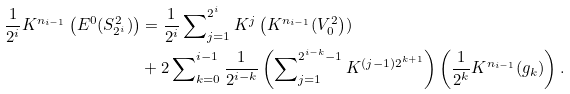Convert formula to latex. <formula><loc_0><loc_0><loc_500><loc_500>\frac { 1 } { 2 ^ { i } } K ^ { n _ { i - 1 } } \left ( E ^ { 0 } ( S _ { 2 ^ { i } } ^ { 2 } ) \right ) & = \frac { 1 } { 2 ^ { i } } \sum \nolimits _ { j = 1 } ^ { 2 ^ { i } } K ^ { j } \left ( K ^ { n _ { i - 1 } } ( V _ { 0 } ^ { 2 } \right ) ) \\ & + 2 \sum \nolimits _ { k = 0 } ^ { i - 1 } \frac { 1 } { 2 ^ { i - k } } \left ( \sum \nolimits _ { j = 1 } ^ { 2 ^ { i - k } - 1 } K ^ { ( j - 1 ) 2 ^ { k + 1 } } \right ) \left ( \frac { 1 } { 2 ^ { k } } K ^ { n _ { i - 1 } } ( g _ { k } ) \right ) .</formula> 